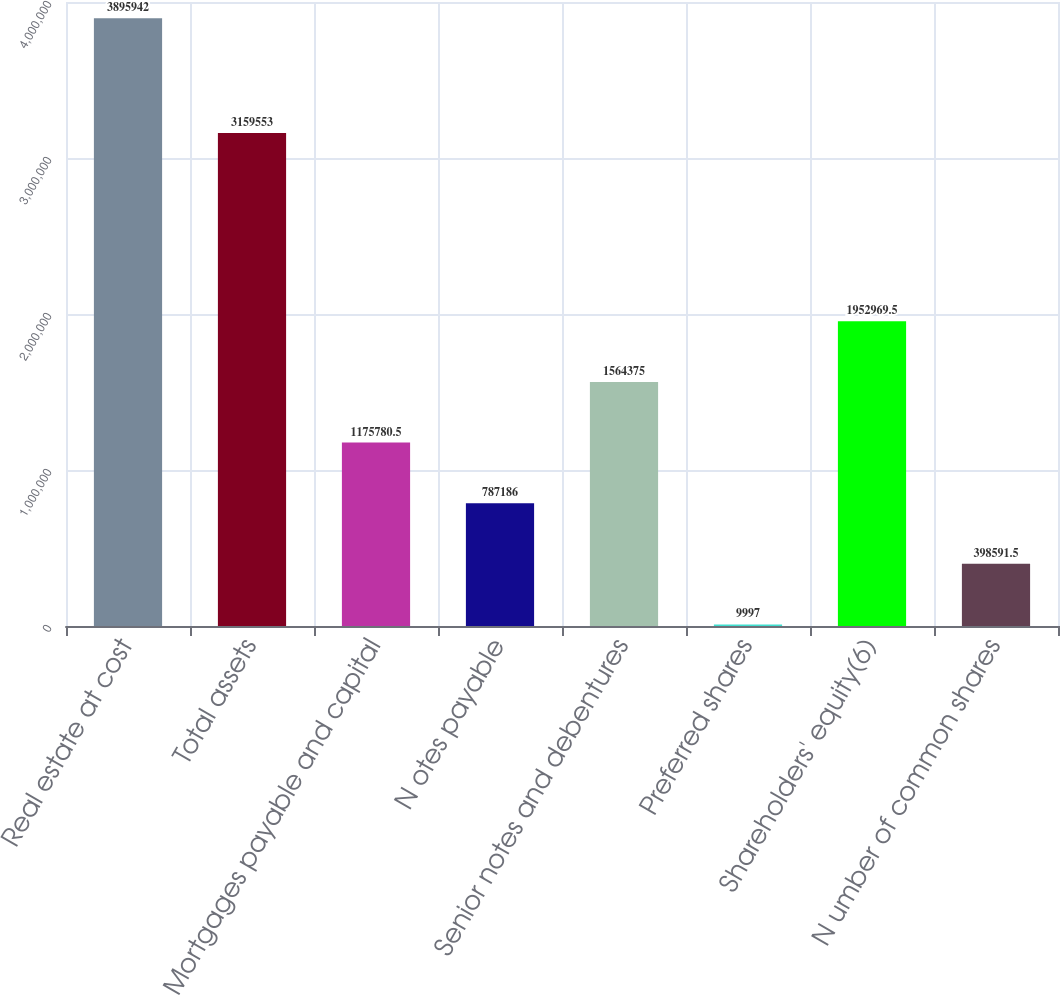<chart> <loc_0><loc_0><loc_500><loc_500><bar_chart><fcel>Real estate at cost<fcel>Total assets<fcel>Mortgages payable and capital<fcel>N otes payable<fcel>Senior notes and debentures<fcel>Preferred shares<fcel>Shareholders' equity(6)<fcel>N umber of common shares<nl><fcel>3.89594e+06<fcel>3.15955e+06<fcel>1.17578e+06<fcel>787186<fcel>1.56438e+06<fcel>9997<fcel>1.95297e+06<fcel>398592<nl></chart> 